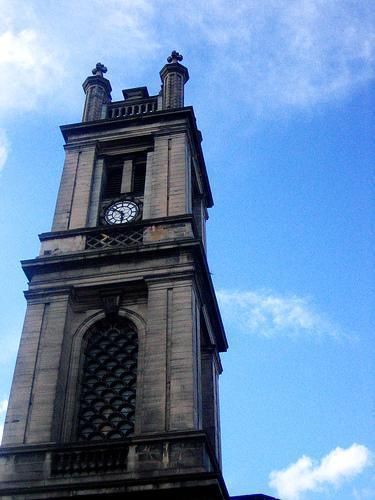How many pillars are shown at the top of the tower?
Give a very brief answer. 2. How many clocks are shown?
Give a very brief answer. 1. How many people are wearing an orange shirt?
Give a very brief answer. 0. 